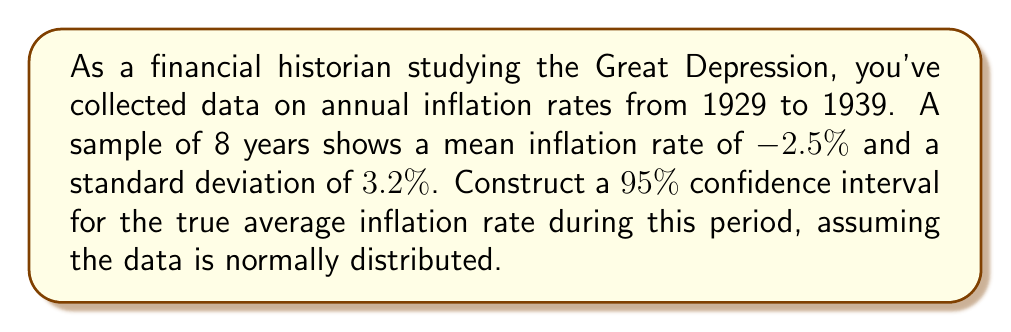Solve this math problem. To construct a 95% confidence interval for the mean inflation rate, we'll use the t-distribution since we have a small sample size (n < 30) and the population standard deviation is unknown. Let's follow these steps:

1. Identify the given information:
   - Sample size: n = 8
   - Sample mean: $\bar{x} = -2.5\%$
   - Sample standard deviation: s = 3.2%
   - Confidence level: 95% (α = 0.05)

2. Determine the degrees of freedom:
   df = n - 1 = 8 - 1 = 7

3. Find the critical t-value for a 95% confidence interval with 7 degrees of freedom:
   $t_{0.025, 7} = 2.365$ (from t-distribution table)

4. Calculate the standard error of the mean:
   $SE = \frac{s}{\sqrt{n}} = \frac{3.2}{\sqrt{8}} = 1.131\%$

5. Compute the margin of error:
   $ME = t_{0.025, 7} \times SE = 2.365 \times 1.131\% = 2.675\%$

6. Calculate the confidence interval:
   $CI = \bar{x} \pm ME$
   $CI = -2.5\% \pm 2.675\%$
   $CI = (-5.175\%, 0.175\%)$

Therefore, we can be 95% confident that the true average inflation rate during the Great Depression period falls between -5.175% and 0.175%.
Answer: (-5.175%, 0.175%) 